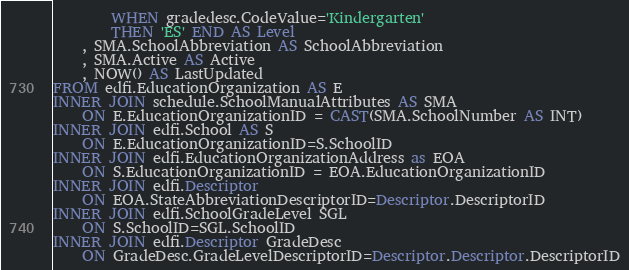Convert code to text. <code><loc_0><loc_0><loc_500><loc_500><_SQL_>        WHEN gradedesc.CodeValue='Kindergarten'
        THEN 'ES' END AS Level
    , SMA.SchoolAbbreviation AS SchoolAbbreviation
    , SMA.Active AS Active
    , NOW() AS LastUpdated
FROM edfi.EducationOrganization AS E
INNER JOIN schedule.SchoolManualAttributes AS SMA
    ON E.EducationOrganizationID = CAST(SMA.SchoolNumber AS INT)
INNER JOIN edfi.School AS S
    ON E.EducationOrganizationID=S.SchoolID
INNER JOIN edfi.EducationOrganizationAddress as EOA
	ON S.EducationOrganizationID = EOA.EducationOrganizationID
INNER JOIN edfi.Descriptor 
	ON EOA.StateAbbreviationDescriptorID=Descriptor.DescriptorID
INNER JOIN edfi.SchoolGradeLevel SGL
    ON S.SchoolID=SGL.SchoolID
INNER JOIN edfi.Descriptor GradeDesc
    ON GradeDesc.GradeLevelDescriptorID=Descriptor.Descriptor.DescriptorID
</code> 